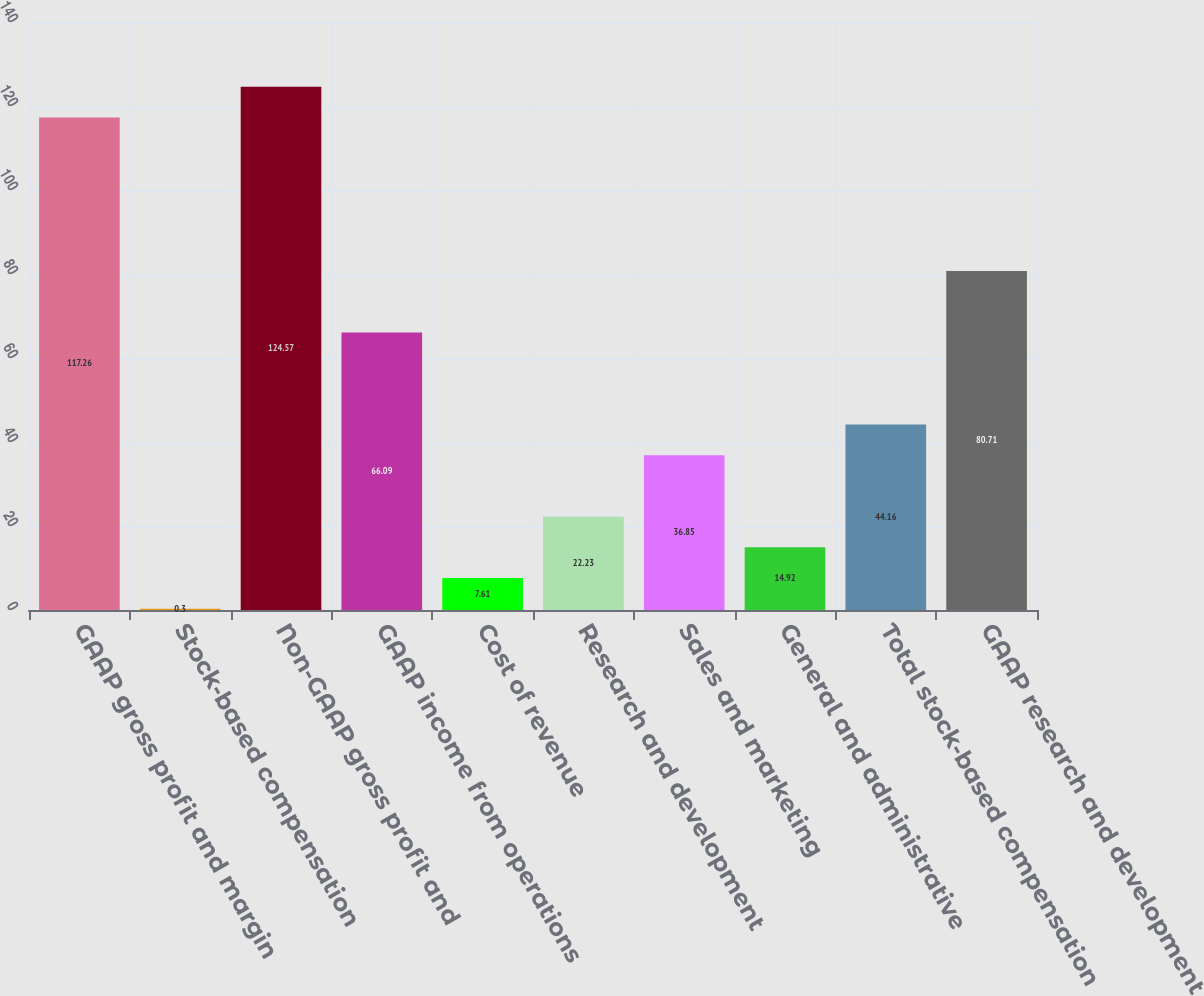<chart> <loc_0><loc_0><loc_500><loc_500><bar_chart><fcel>GAAP gross profit and margin<fcel>Stock-based compensation<fcel>Non-GAAP gross profit and<fcel>GAAP income from operations<fcel>Cost of revenue<fcel>Research and development<fcel>Sales and marketing<fcel>General and administrative<fcel>Total stock-based compensation<fcel>GAAP research and development<nl><fcel>117.26<fcel>0.3<fcel>124.57<fcel>66.09<fcel>7.61<fcel>22.23<fcel>36.85<fcel>14.92<fcel>44.16<fcel>80.71<nl></chart> 